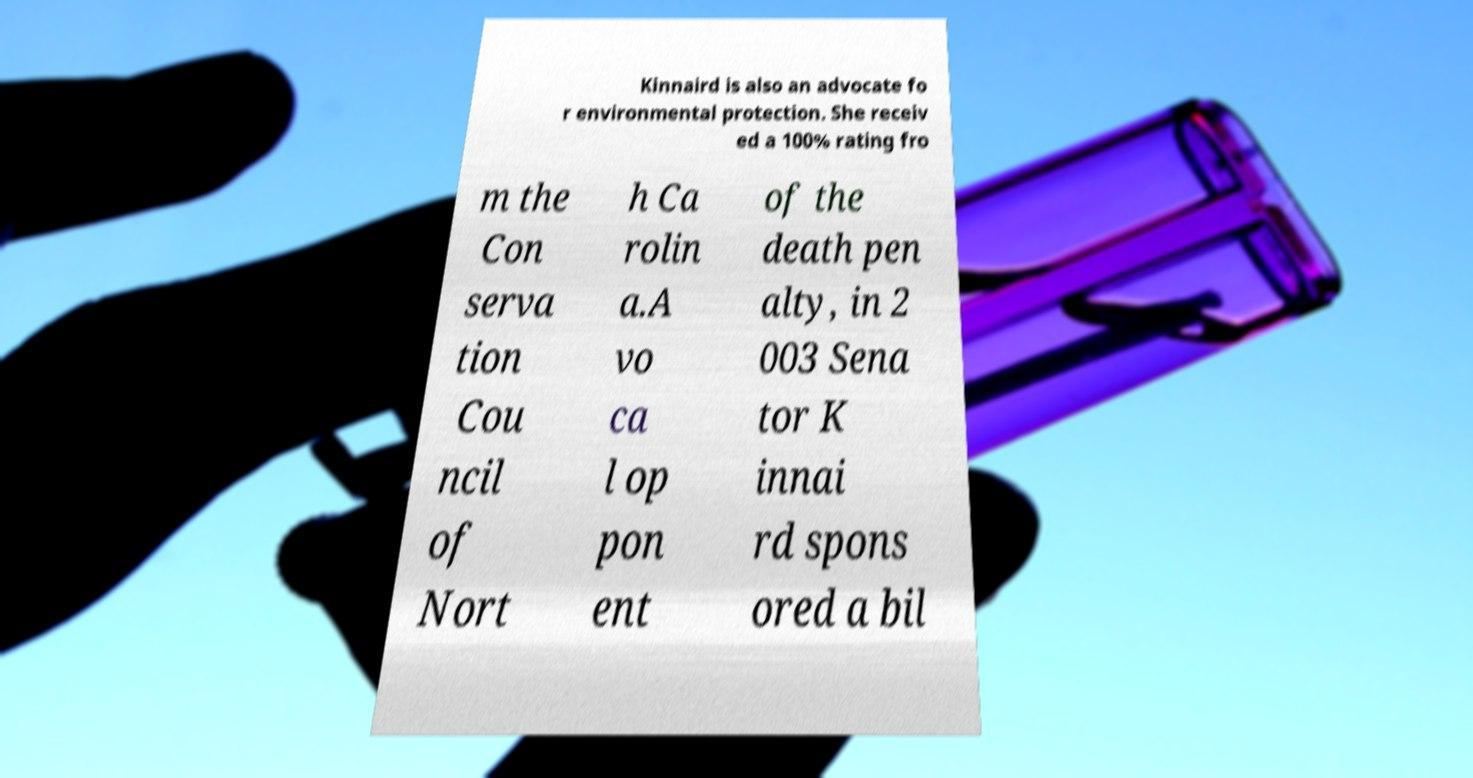For documentation purposes, I need the text within this image transcribed. Could you provide that? Kinnaird is also an advocate fo r environmental protection. She receiv ed a 100% rating fro m the Con serva tion Cou ncil of Nort h Ca rolin a.A vo ca l op pon ent of the death pen alty, in 2 003 Sena tor K innai rd spons ored a bil 